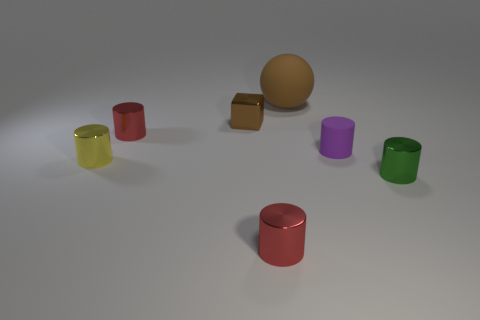How many big things are purple objects or blue objects?
Offer a terse response. 0. How big is the brown object that is right of the small brown object?
Offer a terse response. Large. Is there a tiny matte thing that has the same color as the rubber sphere?
Ensure brevity in your answer.  No. Does the ball have the same color as the small rubber cylinder?
Keep it short and to the point. No. What shape is the tiny object that is the same color as the sphere?
Your answer should be very brief. Cube. There is a small metallic object to the right of the big brown rubber sphere; what number of tiny red cylinders are behind it?
Provide a short and direct response. 1. How many big cyan cubes have the same material as the big brown thing?
Your response must be concise. 0. Are there any brown metallic blocks in front of the tiny brown metallic object?
Give a very brief answer. No. There is a rubber object that is the same size as the metal cube; what color is it?
Your answer should be very brief. Purple. How many objects are either tiny metal things behind the small matte object or brown objects?
Offer a terse response. 3. 